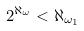Convert formula to latex. <formula><loc_0><loc_0><loc_500><loc_500>2 ^ { \aleph _ { \omega } } < \aleph _ { \omega _ { 1 } }</formula> 